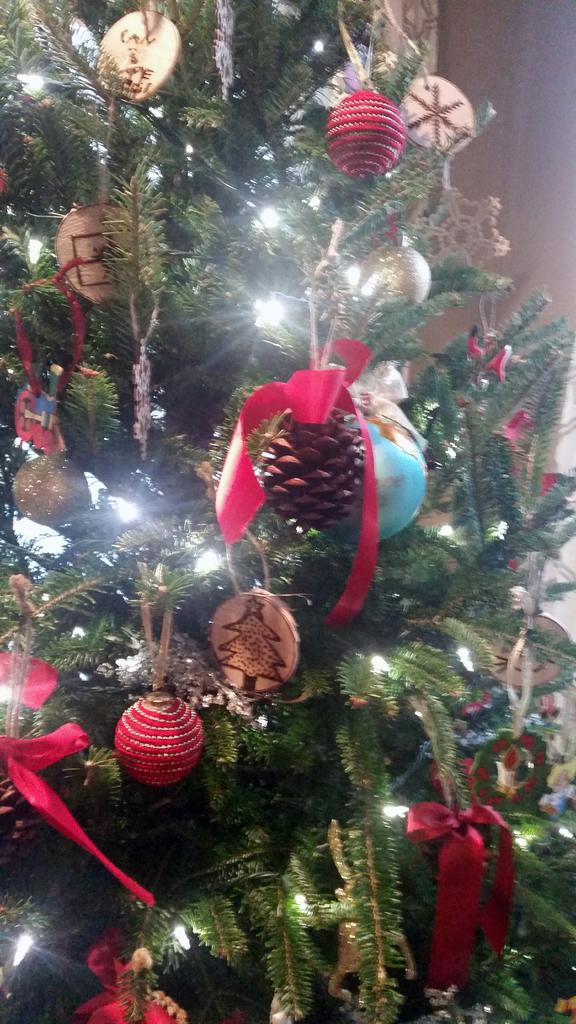What type of tree is decorated in the image? There is a decorated Christmas tree in the image. What can be seen on the Christmas tree? The tree has lights and ribbons on it, as well as other objects. Can you describe the lights on the Christmas tree? The lights on the Christmas tree are not described in the facts, but we can see that they are present on the tree. What type of toy is the creator of the Christmas tree holding in the image? There is no toy or creator present in the image; it only shows a decorated Christmas tree. 